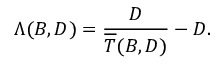Convert formula to latex. <formula><loc_0><loc_0><loc_500><loc_500>\Lambda ( B , D ) = \frac { D } { \overline { T } ( B , D ) } - D .</formula> 